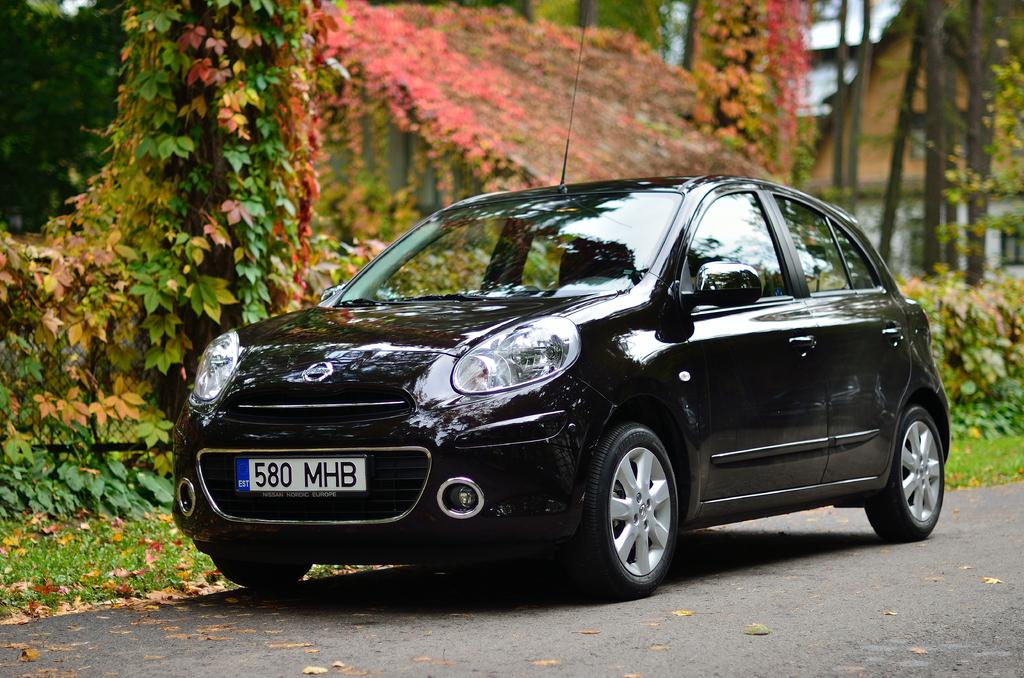What color is the car in the image? The car in the image is black. Where is the car located in the image? The car is on the road in the image. What can be seen behind the car in the image? There are plants and trees behind the car in the image. What type of machine is performing an action in the image? There is no machine performing an action in the image; it only features a black car on the road with plants and trees behind it. 